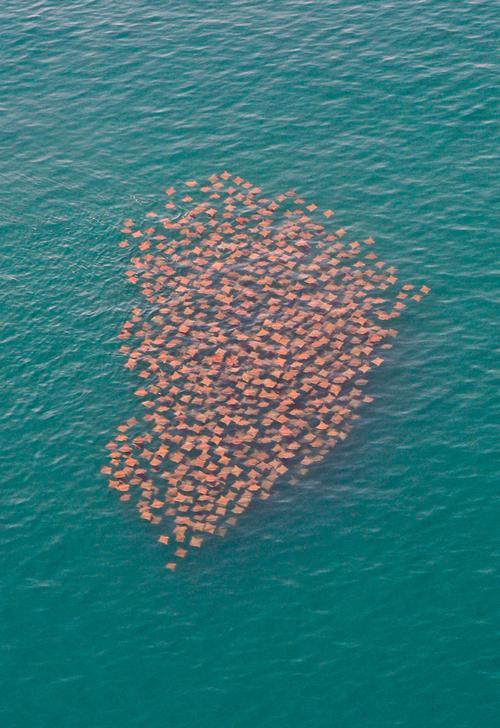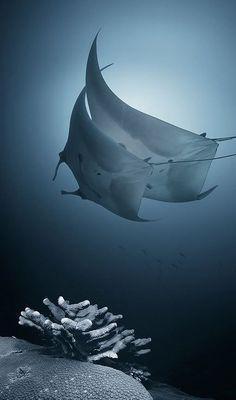The first image is the image on the left, the second image is the image on the right. For the images shown, is this caption "There are no more than 8 creatures in the image on the right." true? Answer yes or no. Yes. 